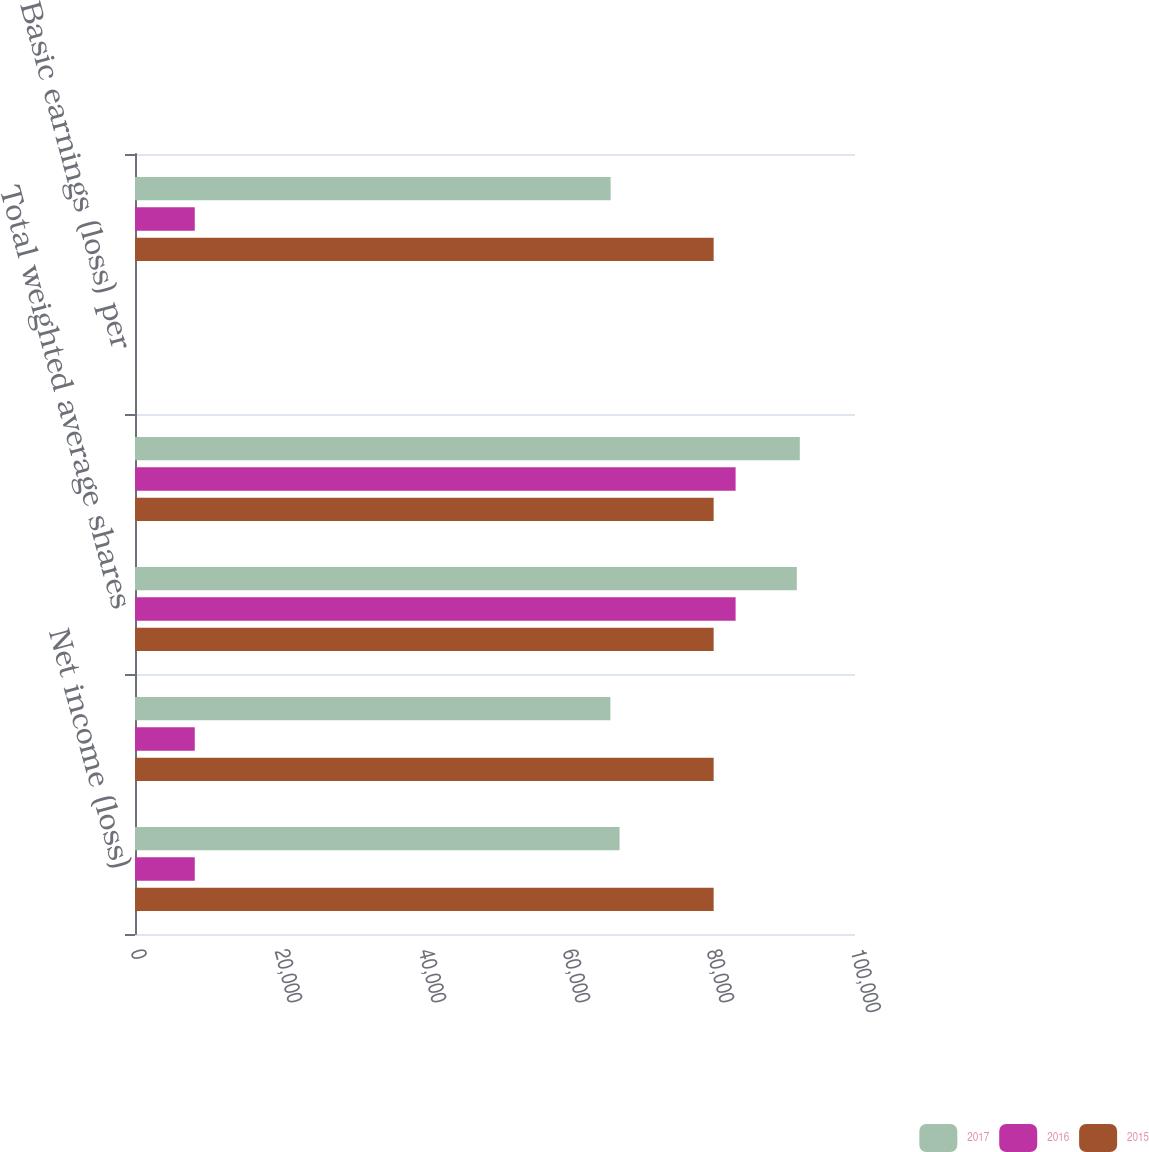Convert chart. <chart><loc_0><loc_0><loc_500><loc_500><stacked_bar_chart><ecel><fcel>Net income (loss)<fcel>Net income (loss) for basic<fcel>Total weighted average shares<fcel>Weighted average common shares<fcel>Basic earnings (loss) per<fcel>Net income (loss) for diluted<nl><fcel>2017<fcel>67303<fcel>66028<fcel>91921<fcel>92332<fcel>0.73<fcel>66057<nl><fcel>2016<fcel>8302<fcel>8302<fcel>83417<fcel>83417<fcel>0.1<fcel>8302<nl><fcel>2015<fcel>80367<fcel>80367<fcel>80367<fcel>80367<fcel>3.48<fcel>80367<nl></chart> 